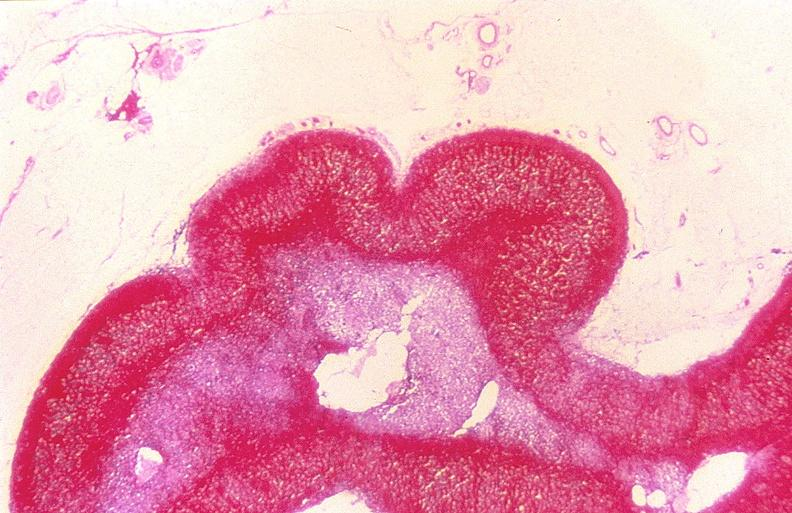does stillborn cord around neck show adrenal gland, severe hemorrhage waterhouse-friderichsen syndrome?
Answer the question using a single word or phrase. No 